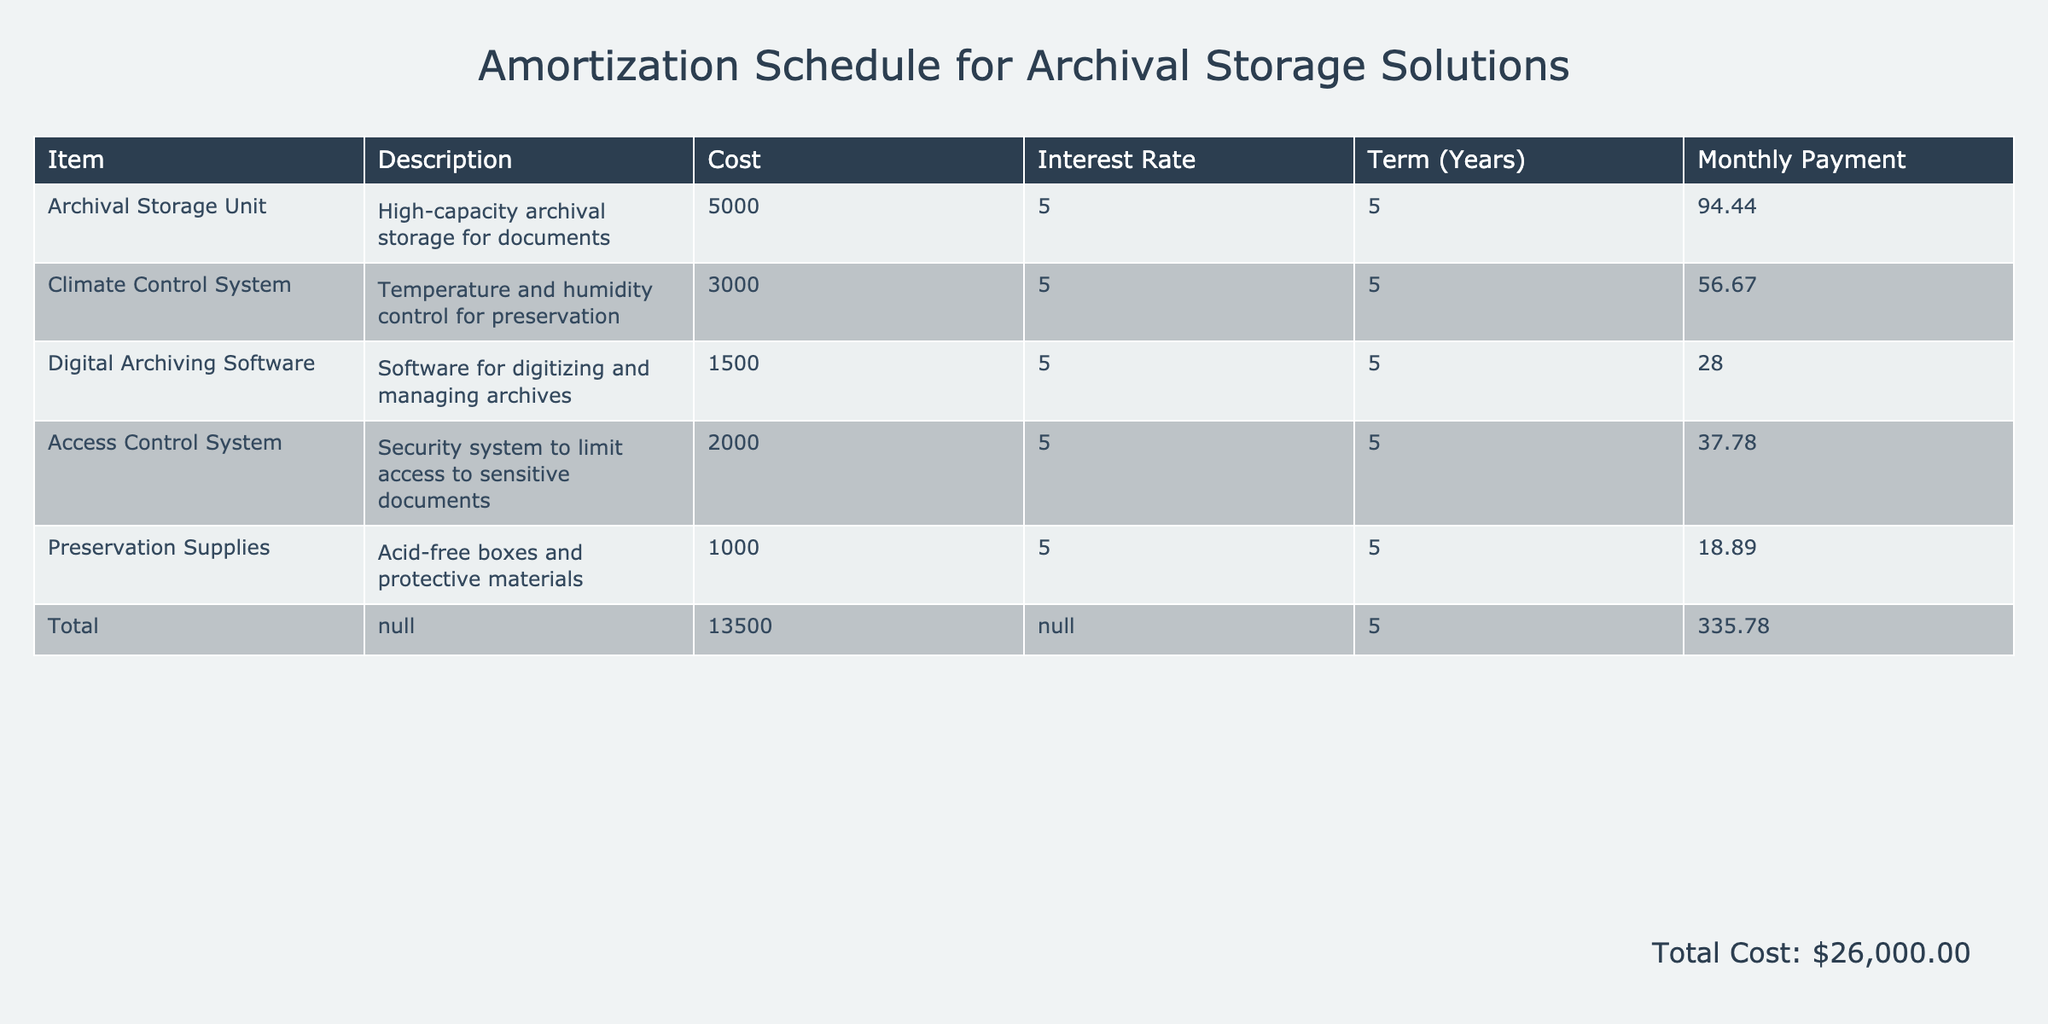What is the monthly payment for the Climate Control System? The table lists the monthly payment for the Climate Control System under the "Monthly Payment" column. The value is directly found, which is 56.67.
Answer: 56.67 What is the total cost of all archival storage solutions? The "Total" row in the table sums the costs of each item listed above. The total cost provided is 13500.
Answer: 13500 Is the cost of Digital Archiving Software greater than the Preservation Supplies? Comparing the costs from the "Cost" column, Digital Archiving Software is 1500 and Preservation Supplies is 1000. Since 1500 is greater than 1000, the statement is true.
Answer: Yes What percentage of the total cost does the Archival Storage Unit represent? First, find the cost of the Archival Storage Unit, which is 5000. Next, calculate the percentage by using the formula (5000 / 13500) * 100, which results in approximately 37.04%.
Answer: 37.04% If the interest rate were to increase by 1%, what would be the new monthly payment for the Archival Storage Unit under the same term? The original monthly payment for the Archival Storage Unit is 94.44 based on a 5% interest rate. If the new interest rate is 6%, we must calculate a new monthly payment using financial formulas to account for the change. This requires complex financial calculations specific to amortization. The answer is beyond simple retrieval from the table.
Answer: Requires calculation What are the two most expensive items in the list? Review the "Cost" column and identify the two highest values. The Archival Storage Unit (5000) and Climate Control System (3000) are the two most expensive items.
Answer: Archival Storage Unit and Climate Control System Does the total cost exceed 15000? The total cost of all items, as mentioned in the "Total" row, is 13500, which does not exceed 15000. Thus, the statement is false.
Answer: No What is the average monthly payment for all items listed? To find the average, sum all monthly payments (94.44 + 56.67 + 28.00 + 37.78 + 18.89 = 335.78), then divide this sum by the number of items (5), resulting in an average monthly payment of 67.16.
Answer: 67.16 What is the lowest cost item in the table? Look through the "Cost" column for the smallest value, which is 1000 for Preservation Supplies.
Answer: 1000 